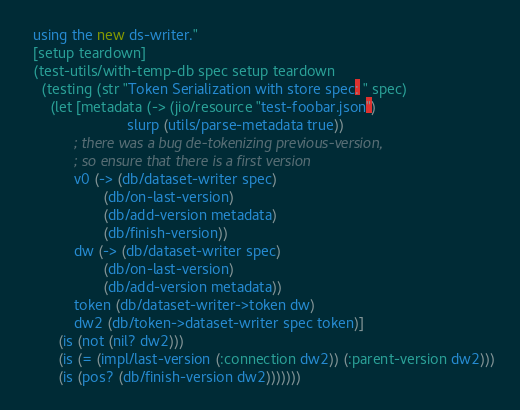<code> <loc_0><loc_0><loc_500><loc_500><_Clojure_>  using the new ds-writer."
  [setup teardown]
  (test-utils/with-temp-db spec setup teardown
    (testing (str "Token Serialization with store spec: " spec)
      (let [metadata (-> (jio/resource "test-foobar.json")
                         slurp (utils/parse-metadata true))
            ; there was a bug de-tokenizing previous-version,
            ; so ensure that there is a first version
            v0 (-> (db/dataset-writer spec)
                   (db/on-last-version)
                   (db/add-version metadata)
                   (db/finish-version))
            dw (-> (db/dataset-writer spec)
                   (db/on-last-version)
                   (db/add-version metadata))
            token (db/dataset-writer->token dw)
            dw2 (db/token->dataset-writer spec token)]
        (is (not (nil? dw2)))
        (is (= (impl/last-version (:connection dw2)) (:parent-version dw2)))
        (is (pos? (db/finish-version dw2)))))))

</code> 